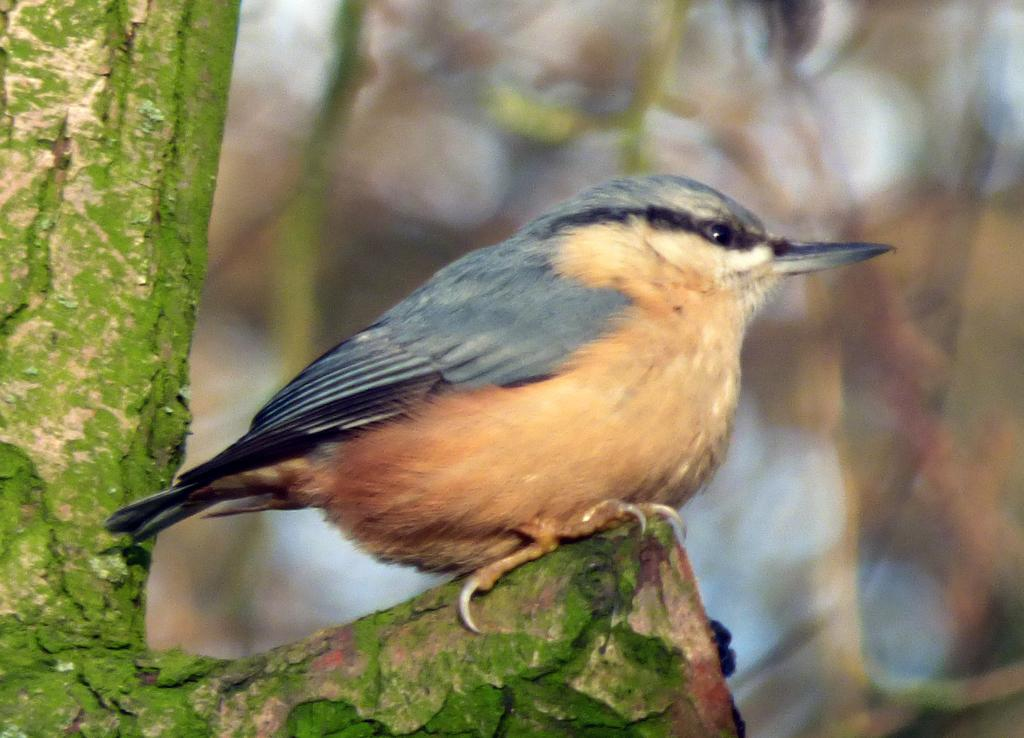What is the main subject of the picture? The main subject of the picture is a bird. Where is the bird located in the image? The bird is sitting on a branch of a tree. Can you describe the background of the image? The background of the image is blurry. What type of calculator can be seen in the image? There is no calculator present in the image. Can you hear the bird singing in the image? The image is not accompanied by sound, so it is not possible to hear the bird singing. 